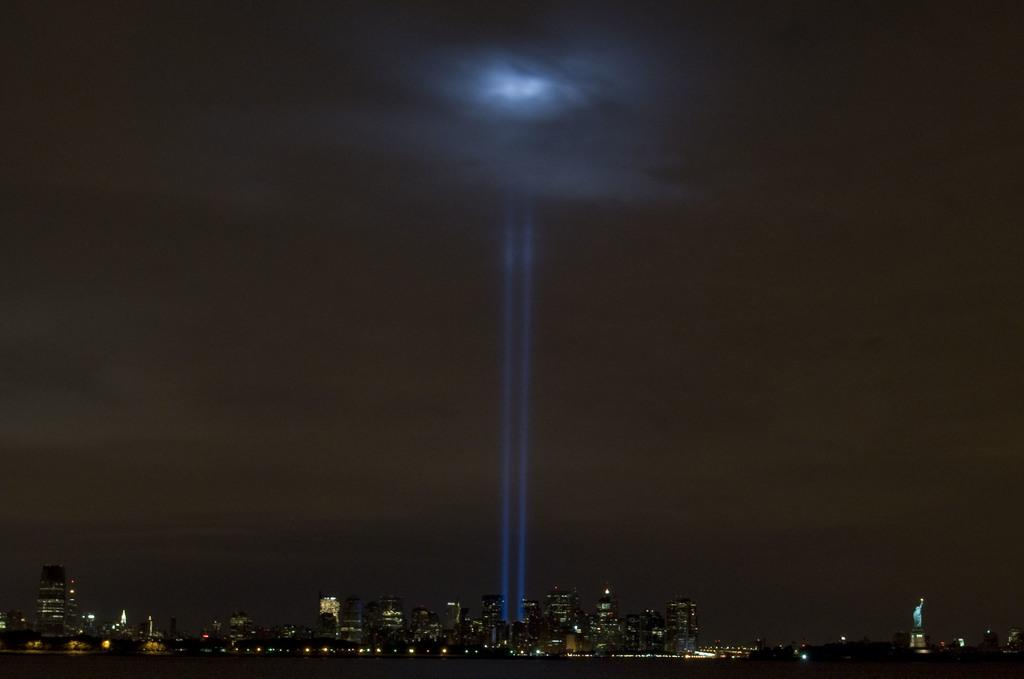What type of structures can be seen in the image? There are buildings in the image. What else is visible in the image besides the buildings? There are lights and a statue in the image. What is visible at the top of the image? The sky is visible at the top of the image. Where is the throne located in the image? There is no throne present in the image. What type of ice is used to create the statue in the image? There is no ice used to create the statue in the image; it is likely made of a different material, such as stone or metal. 